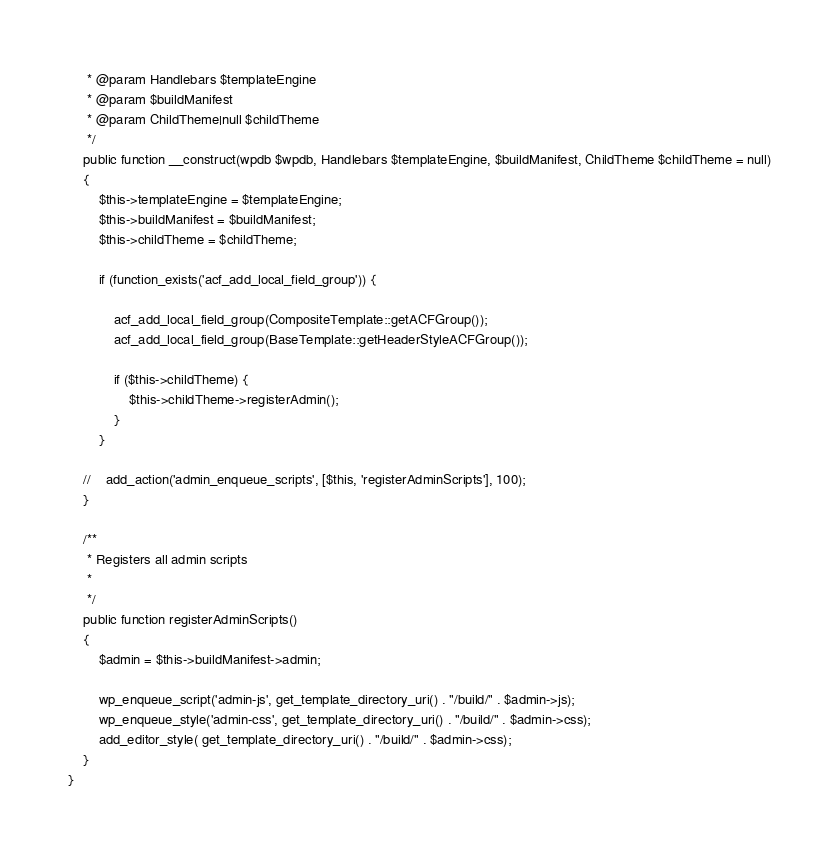<code> <loc_0><loc_0><loc_500><loc_500><_PHP_>     * @param Handlebars $templateEngine
     * @param $buildManifest
     * @param ChildTheme|null $childTheme
     */
    public function __construct(wpdb $wpdb, Handlebars $templateEngine, $buildManifest, ChildTheme $childTheme = null)
    {
        $this->templateEngine = $templateEngine;
        $this->buildManifest = $buildManifest;
        $this->childTheme = $childTheme;

        if (function_exists('acf_add_local_field_group')) {

            acf_add_local_field_group(CompositeTemplate::getACFGroup());
            acf_add_local_field_group(BaseTemplate::getHeaderStyleACFGroup());

            if ($this->childTheme) {
                $this->childTheme->registerAdmin();
            }
        }

    //    add_action('admin_enqueue_scripts', [$this, 'registerAdminScripts'], 100);
    }

    /**
     * Registers all admin scripts
     *
     */
    public function registerAdminScripts()
    {
        $admin = $this->buildManifest->admin;

        wp_enqueue_script('admin-js', get_template_directory_uri() . "/build/" . $admin->js);
        wp_enqueue_style('admin-css', get_template_directory_uri() . "/build/" . $admin->css);
        add_editor_style( get_template_directory_uri() . "/build/" . $admin->css);
    }
}</code> 